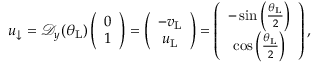Convert formula to latex. <formula><loc_0><loc_0><loc_500><loc_500>\begin{array} { r } { u _ { \downarrow } = \mathcal { D } _ { y } ( \theta _ { L } ) \left ( \begin{array} { c } { 0 } \\ { 1 } \end{array} \right ) = \left ( \begin{array} { c } { - v _ { L } } \\ { u _ { L } } \end{array} \right ) = \left ( \begin{array} { c c } { - \sin \left ( \frac { \theta _ { L } } { 2 } \right ) } \\ { \cos \left ( \frac { \theta _ { L } } { 2 } \right ) } \end{array} \right ) , } \end{array}</formula> 